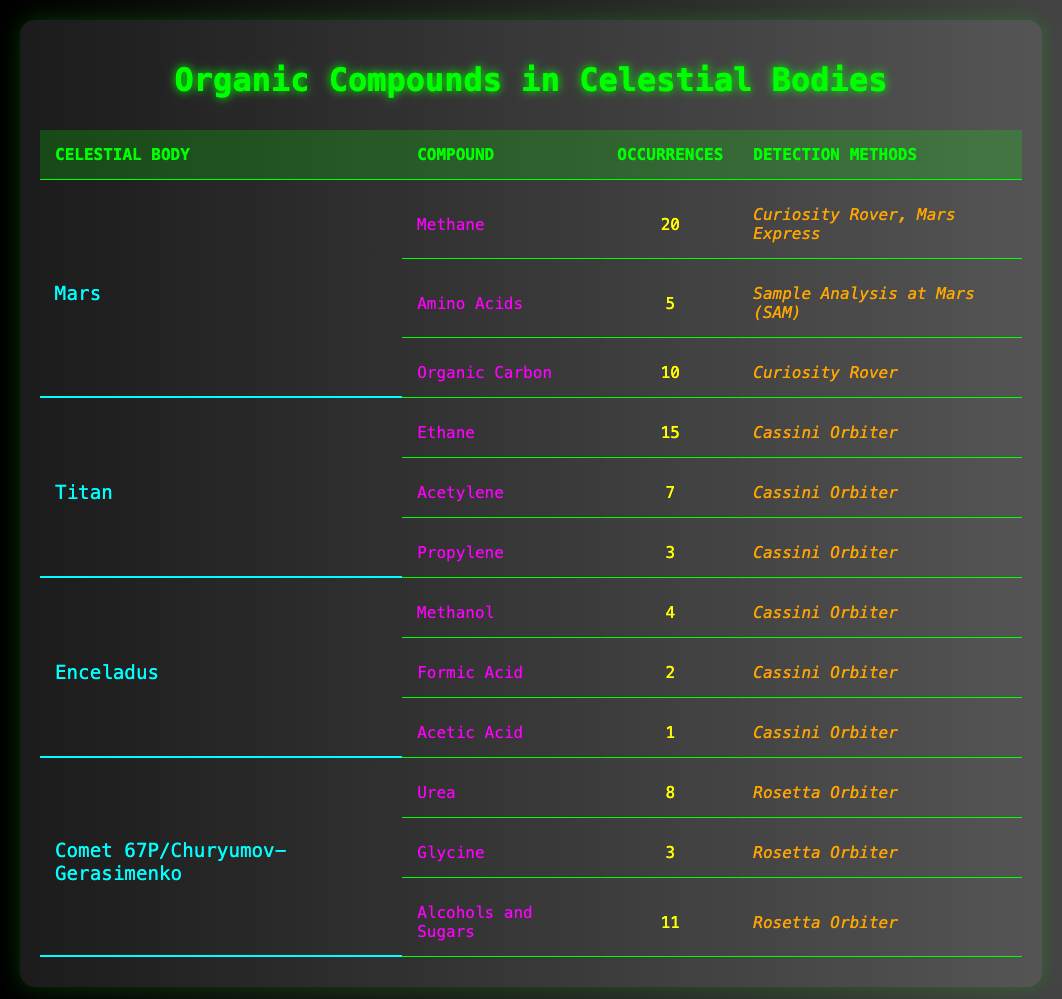What is the total number of occurrences of organic compounds detected on Mars? To find the total occurrences of organic compounds on Mars, we need to sum up the occurrences: Methane (20) + Amino Acids (5) + Organic Carbon (10) = 35.
Answer: 35 Which celestial body has the highest occurrences of organic compounds detected? Comparing the total occurrences for each celestial body: Mars (35), Titan (25), Enceladus (7), Comet 67P (22). Mars has the highest total occurrences.
Answer: Mars Is Methanol detected in more occurrences than Formic Acid on Enceladus? Methanol has 4 occurrences while Formic Acid has 2 occurrences. Since 4 is greater than 2, Methanol is detected in more occurrences.
Answer: Yes What is the average number of occurrences for the organic compounds detected on Titan? Titan has three compounds: Ethane (15), Acetylene (7), and Propylene (3). The average is calculated as (15 + 7 + 3) / 3 = 25 / 3 ≈ 8.33.
Answer: 8.33 On which celestial body was Glycine detected? Glycine was detected on Comet 67P/Churyumov-Gerasimenko, according to the table.
Answer: Comet 67P/Churyumov-Gerasimenko How many detection methods were used for organic compounds on Mars? The methods used are: Curiosity Rover (2 compounds), Mars Express (1 compound), and Sample Analysis at Mars (1 compound). So, there are 3 detection methods total.
Answer: 3 What is the difference in the number of occurrences of Alcohols and Sugars compared to Urea on Comet 67P? Alcohols and Sugars have 11 occurrences, while Urea has 8 occurrences. The difference is 11 - 8 = 3.
Answer: 3 Did any organic compounds detected on Enceladus occur more than 5 times? The highest occurrences on Enceladus is 4 (for Methanol), which is not greater than 5, thus none are above that number.
Answer: No Which celestial body has the lowest total occurrences of organic compounds detected? Summing the occurrences gives us: Mars (35), Titan (25), Enceladus (7), and Comet 67P (22). Enceladus has the lowest at 7 occurrences.
Answer: Enceladus 